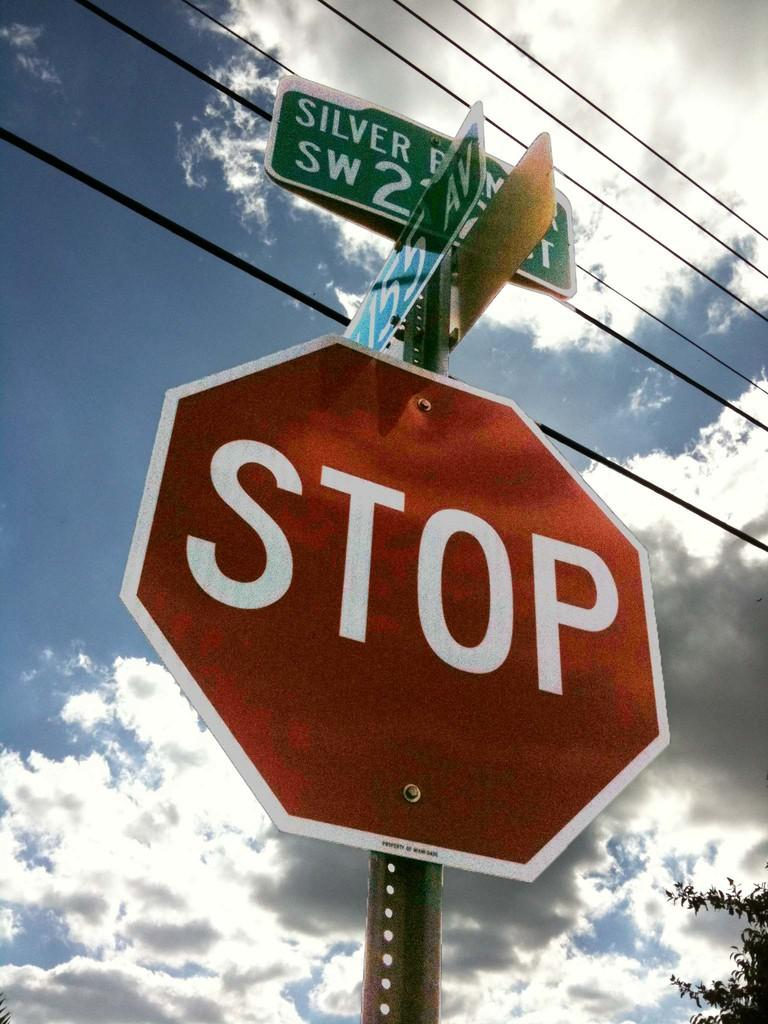<image>
Give a short and clear explanation of the subsequent image. A red sign has the word stop on it and some street signs posted above. 